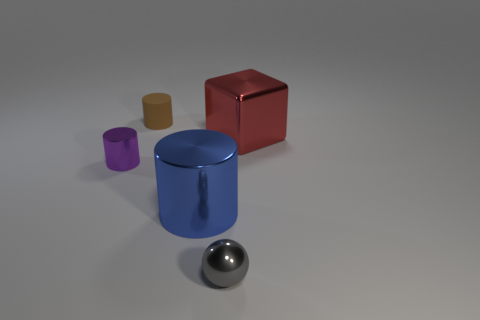What could be the purpose of these objects? Are they usable in real life? These objects seem to be 3D models which may not have a direct real-life function. They are often used in visual arts, computer graphics testing, and educational materials to demonstrate concepts like geometry, lighting, and shading. 